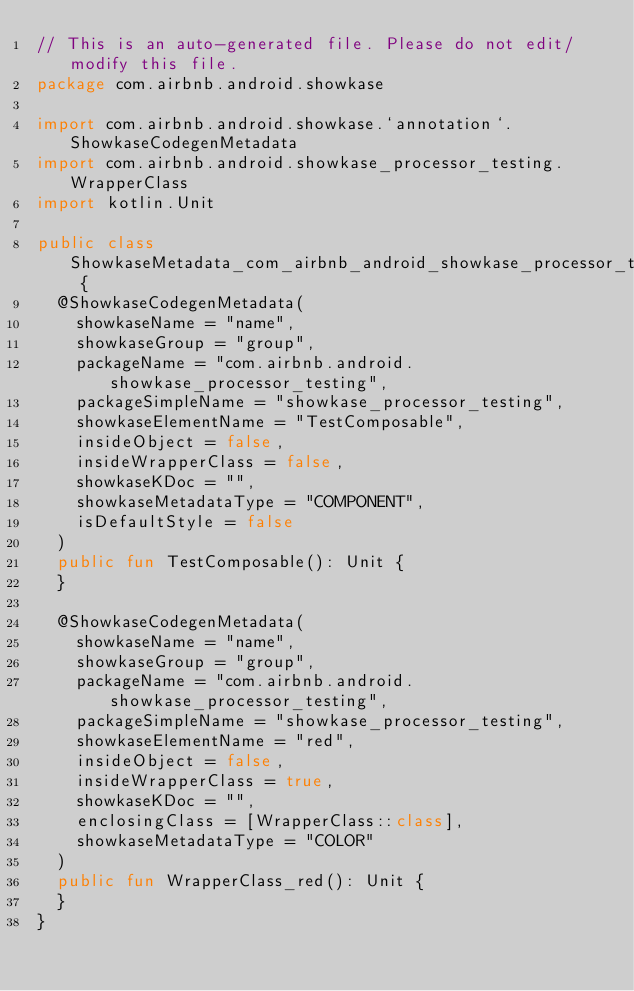<code> <loc_0><loc_0><loc_500><loc_500><_Kotlin_>// This is an auto-generated file. Please do not edit/modify this file.
package com.airbnb.android.showkase

import com.airbnb.android.showkase.`annotation`.ShowkaseCodegenMetadata
import com.airbnb.android.showkase_processor_testing.WrapperClass
import kotlin.Unit

public class ShowkaseMetadata_com_airbnb_android_showkase_processor_testing {
  @ShowkaseCodegenMetadata(
    showkaseName = "name",
    showkaseGroup = "group",
    packageName = "com.airbnb.android.showkase_processor_testing",
    packageSimpleName = "showkase_processor_testing",
    showkaseElementName = "TestComposable",
    insideObject = false,
    insideWrapperClass = false,
    showkaseKDoc = "",
    showkaseMetadataType = "COMPONENT",
    isDefaultStyle = false
  )
  public fun TestComposable(): Unit {
  }

  @ShowkaseCodegenMetadata(
    showkaseName = "name",
    showkaseGroup = "group",
    packageName = "com.airbnb.android.showkase_processor_testing",
    packageSimpleName = "showkase_processor_testing",
    showkaseElementName = "red",
    insideObject = false,
    insideWrapperClass = true,
    showkaseKDoc = "",
    enclosingClass = [WrapperClass::class],
    showkaseMetadataType = "COLOR"
  )
  public fun WrapperClass_red(): Unit {
  }
}
</code> 